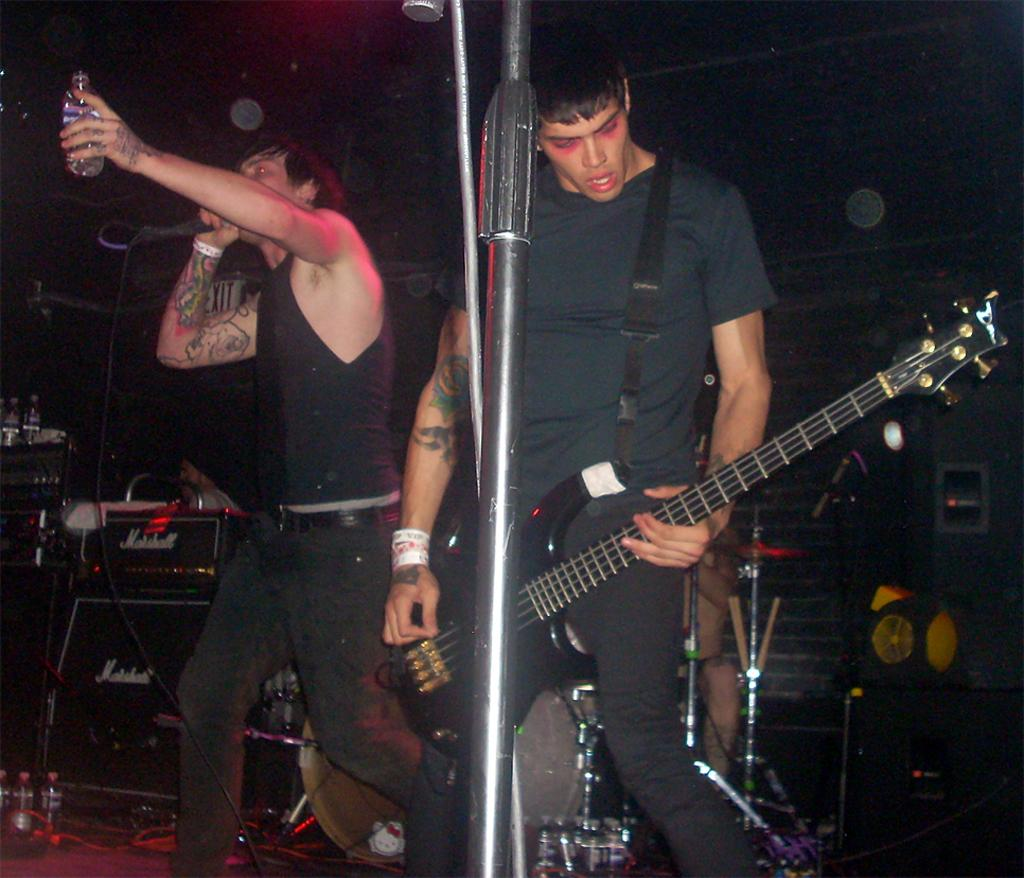How many people are in the image? There are two people in the image. What is the man on the right side holding? The man on the right side is holding a guitar. What is the man on the left side doing? The man on the left side is singing a song. What is the man on the left side holding? The man on the left side is holding a bottle. Is the sponge on the floor being used by the laborer in the image? There is no sponge or laborer present in the image. 